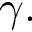Convert formula to latex. <formula><loc_0><loc_0><loc_500><loc_500>\gamma .</formula> 